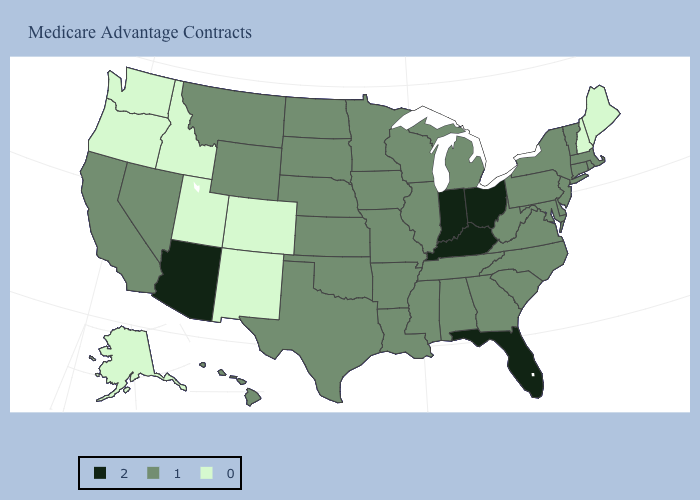What is the value of Texas?
Give a very brief answer. 1. Name the states that have a value in the range 2?
Be succinct. Arizona, Florida, Indiana, Kentucky, Ohio. What is the value of Oklahoma?
Write a very short answer. 1. Among the states that border Texas , which have the highest value?
Write a very short answer. Arkansas, Louisiana, Oklahoma. What is the lowest value in states that border Arizona?
Keep it brief. 0. Name the states that have a value in the range 0?
Be succinct. Alaska, Colorado, Idaho, Maine, New Hampshire, New Mexico, Oregon, Utah, Washington. Which states have the lowest value in the South?
Concise answer only. Alabama, Arkansas, Delaware, Georgia, Louisiana, Maryland, Mississippi, North Carolina, Oklahoma, South Carolina, Tennessee, Texas, Virginia, West Virginia. Name the states that have a value in the range 0?
Answer briefly. Alaska, Colorado, Idaho, Maine, New Hampshire, New Mexico, Oregon, Utah, Washington. What is the lowest value in the MidWest?
Write a very short answer. 1. Name the states that have a value in the range 0?
Short answer required. Alaska, Colorado, Idaho, Maine, New Hampshire, New Mexico, Oregon, Utah, Washington. Name the states that have a value in the range 1?
Be succinct. Alabama, Arkansas, California, Connecticut, Delaware, Georgia, Hawaii, Iowa, Illinois, Kansas, Louisiana, Massachusetts, Maryland, Michigan, Minnesota, Missouri, Mississippi, Montana, North Carolina, North Dakota, Nebraska, New Jersey, Nevada, New York, Oklahoma, Pennsylvania, Rhode Island, South Carolina, South Dakota, Tennessee, Texas, Virginia, Vermont, Wisconsin, West Virginia, Wyoming. Which states have the highest value in the USA?
Write a very short answer. Arizona, Florida, Indiana, Kentucky, Ohio. Which states hav the highest value in the South?
Write a very short answer. Florida, Kentucky. What is the value of Georgia?
Keep it brief. 1. 